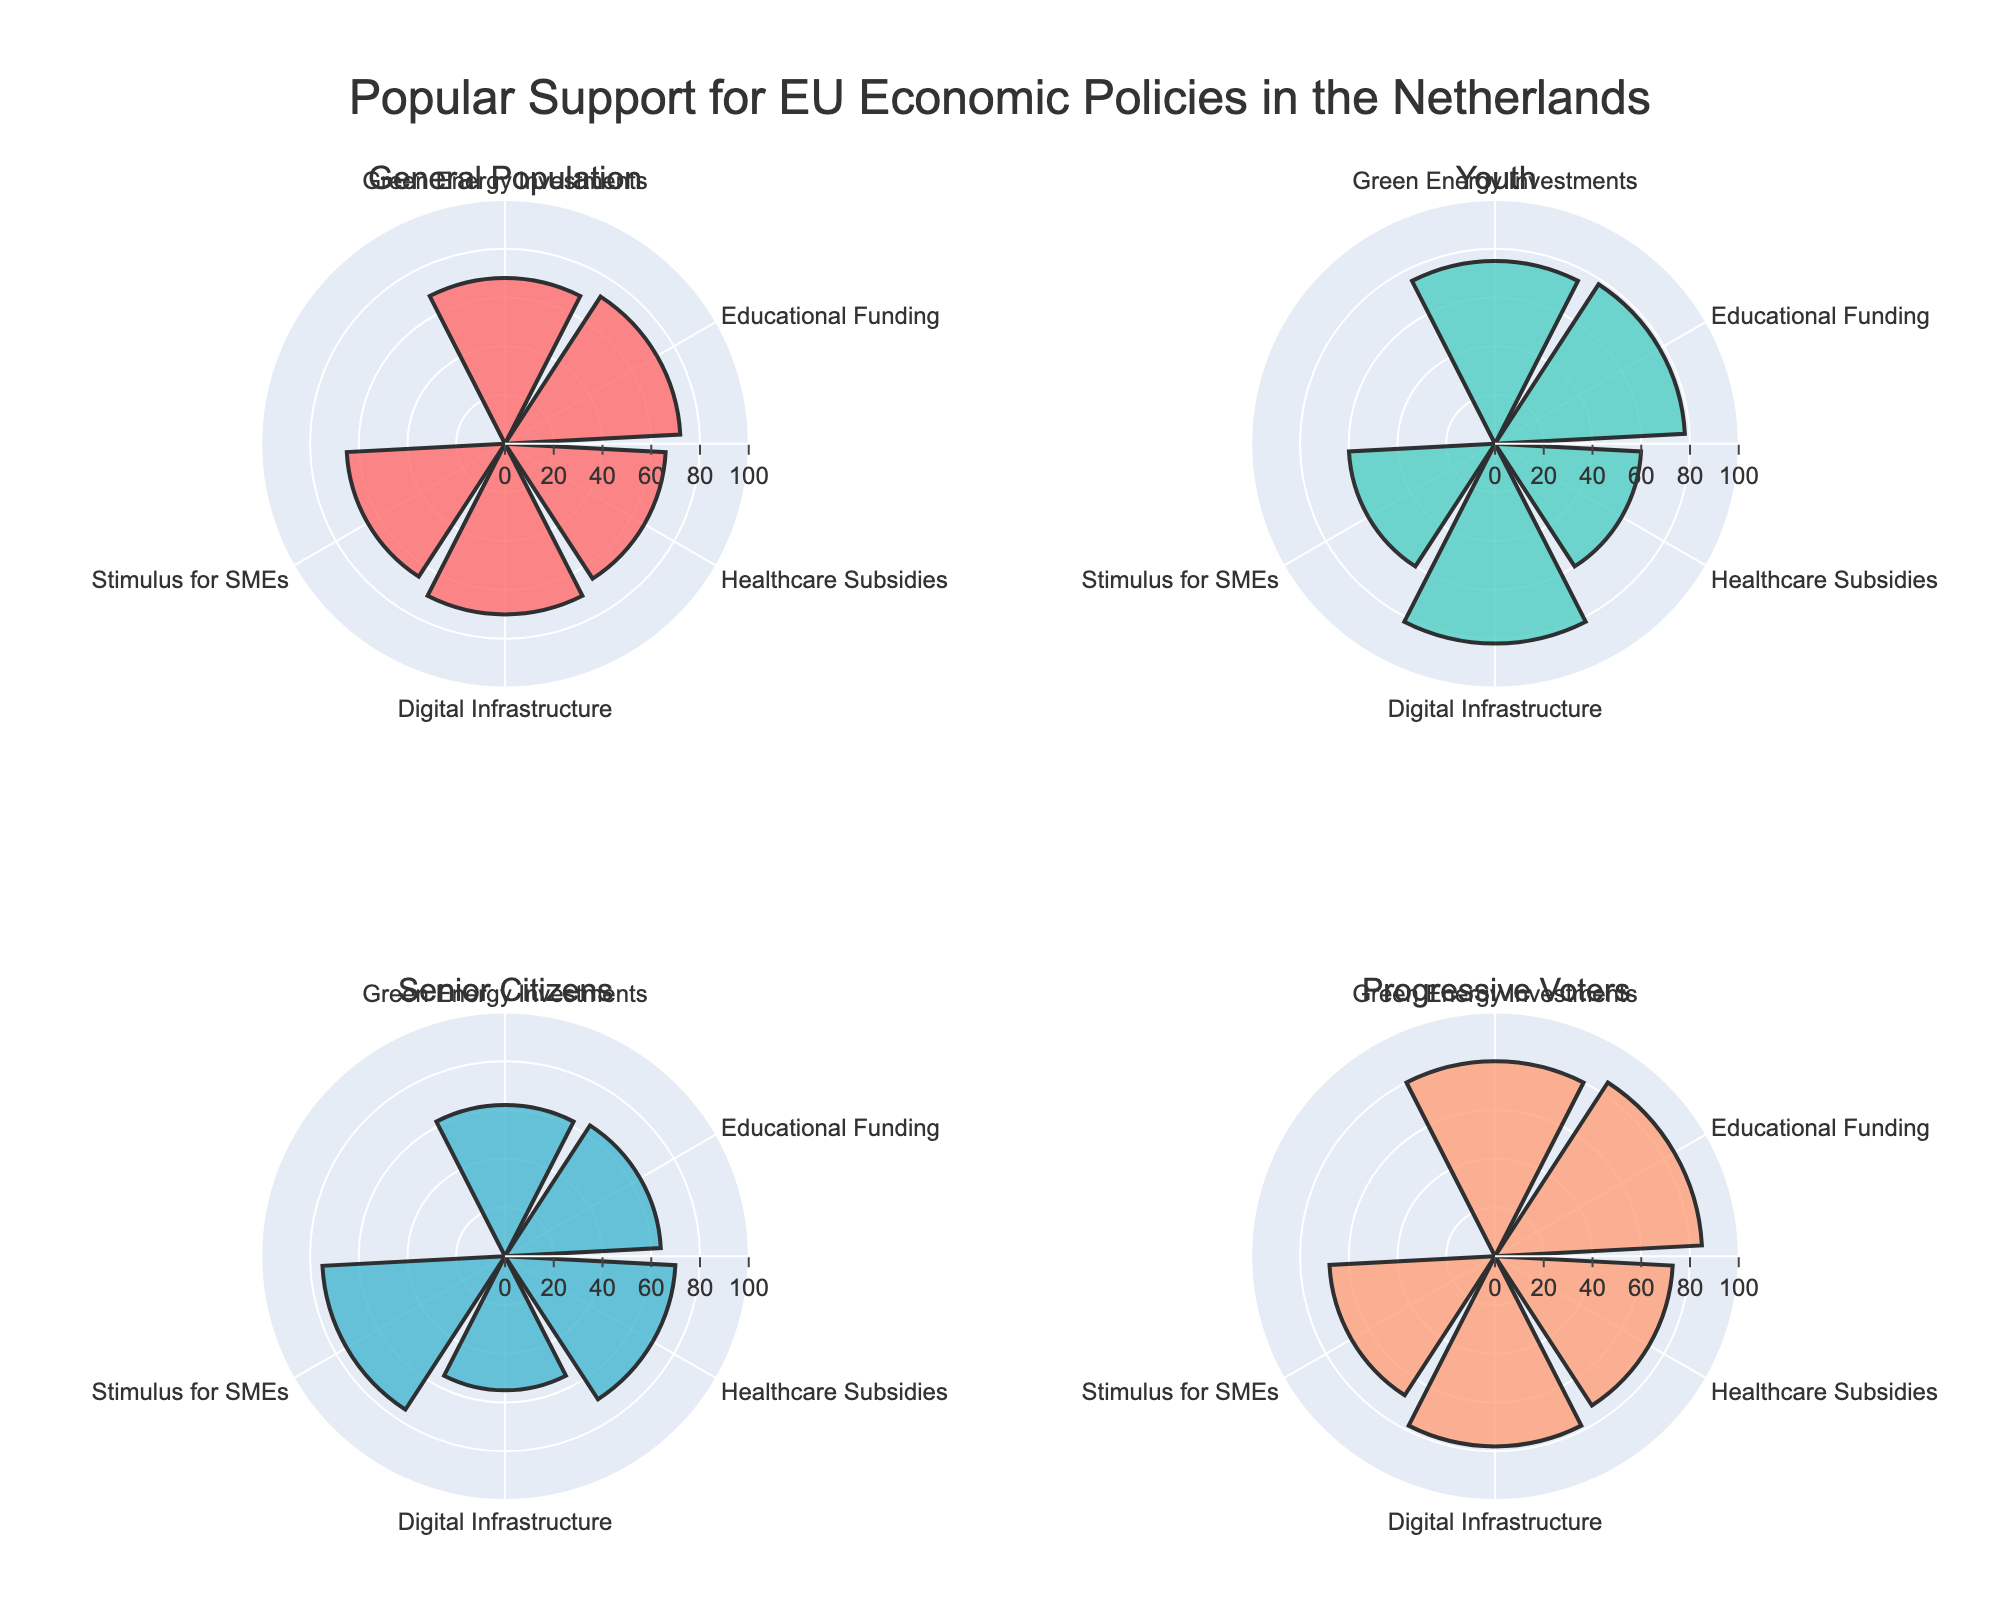What is the support percentage for Green Energy Investments among Senior Citizens? Look at the segment labeled "Green Energy Investments" in the subplot for Senior Citizens and read the radial value.
Answer: 62 Which group shows the highest support for Educational Funding? Analyze all subplots and find the one with the tallest bar for the label "Educational Funding."
Answer: Progressive Voters What is the difference in support for Healthcare Subsidies between Youth and Senior Citizens? Subtract the support percentage for Senior Citizens from that for Youth in the Healthcare Subsidies category (60 - 70).
Answer: -10 What is the average support for Digital Infrastructure across all groups? Sum the support percentages for Digital Infrastructure across all groups and divide by the number of groups: (70 + 82 + 55 + 78) / 4.
Answer: 71.25 Do Progressive Voters show more support for Green Energy Investments or for Educational Funding? Compare the support percentages for Green Energy Investments and Educational Funding in the subplot for Progressive Voters (80 vs 85).
Answer: Educational Funding Which policy receives the least support from the general population? Identify the shortest bar in the General Population subplot and read its label.
Answer: Healthcare Subsidies What is the range of support for Stimulus for SMEs among all age groups? Calculate the difference between the maximum and minimum support percentages for Stimulus for SMEs (75 for Senior Citizens and 60 for Youth).
Answer: 15 Which group has the most uniform support across all policies? Compare the variance of the support percentages across all policies for each group. The group with the smallest range indicates uniform support.
Answer: General Population Is the support for Digital Infrastructure generally higher among Youth or Senior Citizens? Compare the support percentages for Digital Infrastructure in the Youth and Senior Citizens subplots (82 vs 55).
Answer: Youth Which policy shows the biggest discrepancy in support between Youth and Senior Citizens? Identify the absolute difference in support percentages for each policy between Youth and Senior Citizens and find the maximum value.
Answer: Digital Infrastructure 